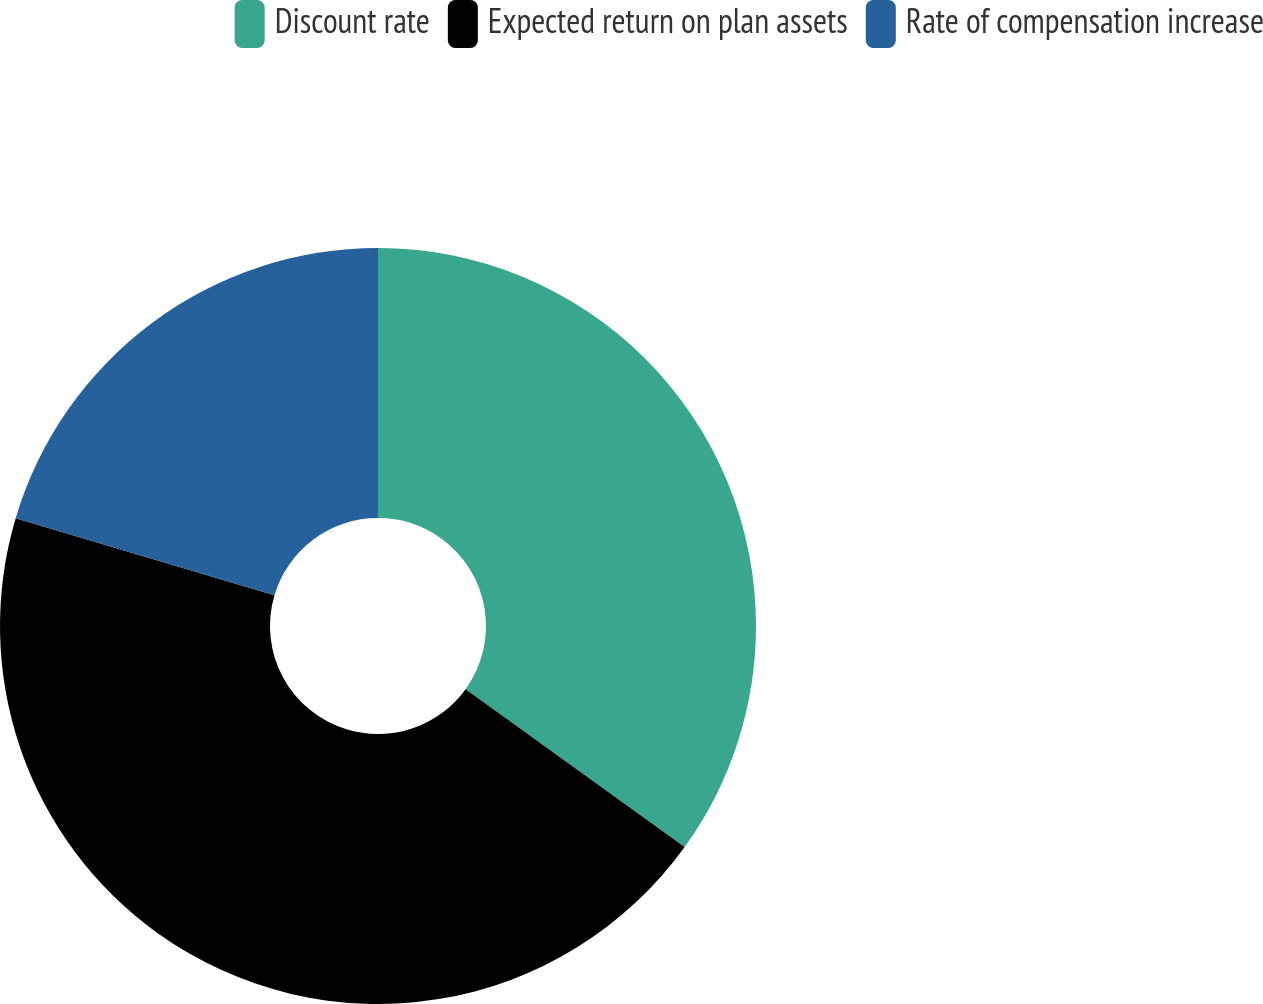<chart> <loc_0><loc_0><loc_500><loc_500><pie_chart><fcel>Discount rate<fcel>Expected return on plan assets<fcel>Rate of compensation increase<nl><fcel>34.94%<fcel>44.66%<fcel>20.4%<nl></chart> 